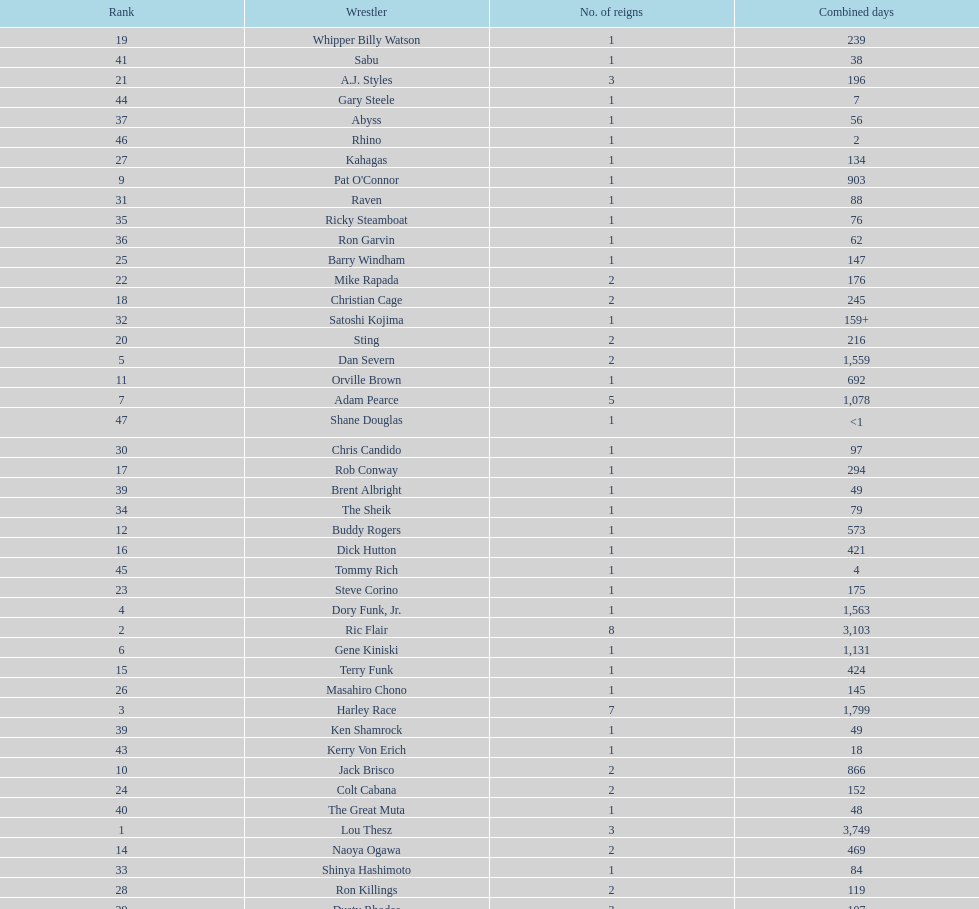How long did orville brown remain nwa world heavyweight champion? 692 days. 